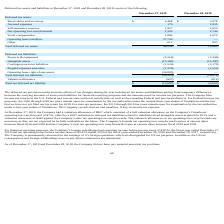From Chefs Wharehouse's financial document, What is the value of Receivables and inventory for 2019 and 2018 respectively? The document shows two values: $4,468 and $3,978. From the document: "Receivables and inventory $ 4,468 $ 3,978 Receivables and inventory $ 4,468 $ 3,978..." Also, What is the value of Accrued expenses for 2019 and 2018 respectively? The document shows two values: 170 and 1,835. From the document: "Accrued expenses 170 1,835 Accrued expenses 170 1,835..." Also, What is the value of Self-insurance reserves for 2019 and 2018 respectively? The document shows two values: 1,957 and 2,050. From the document: "Self-insurance reserves 1,957 2,050 Self-insurance reserves 1,957 2,050..." Also, can you calculate: What is the average value of Receivables and inventory for 2019 and 2018? To answer this question, I need to perform calculations using the financial data. The calculation is: (4,468+ 3,978)/2, which equals 4223. This is based on the information: "Receivables and inventory $ 4,468 $ 3,978 Receivables and inventory $ 4,468 $ 3,978..." The key data points involved are: 3,978, 4,468. Additionally, Which year has the highest Accrued expenses? According to the financial document, 2018. The relevant text states: "liabilities at December 27, 2019 and December 28, 2018 consist of the following:..." Also, can you calculate: What is the change in Stock compensation between 2018 and 2019? Based on the calculation: 1,894-1,670, the result is 224. This is based on the information: "Stock compensation 1,894 1,670 Stock compensation 1,894 1,670..." The key data points involved are: 1,670, 1,894. 